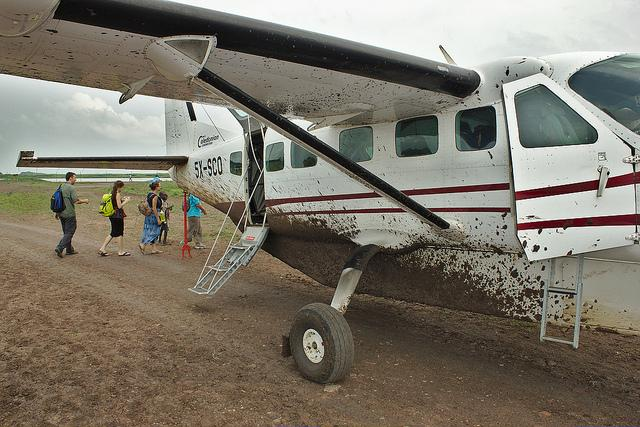What had recently happened when this plane landed prior to this place?

Choices:
A) snow
B) rain
C) sunny day
D) tornado rain 